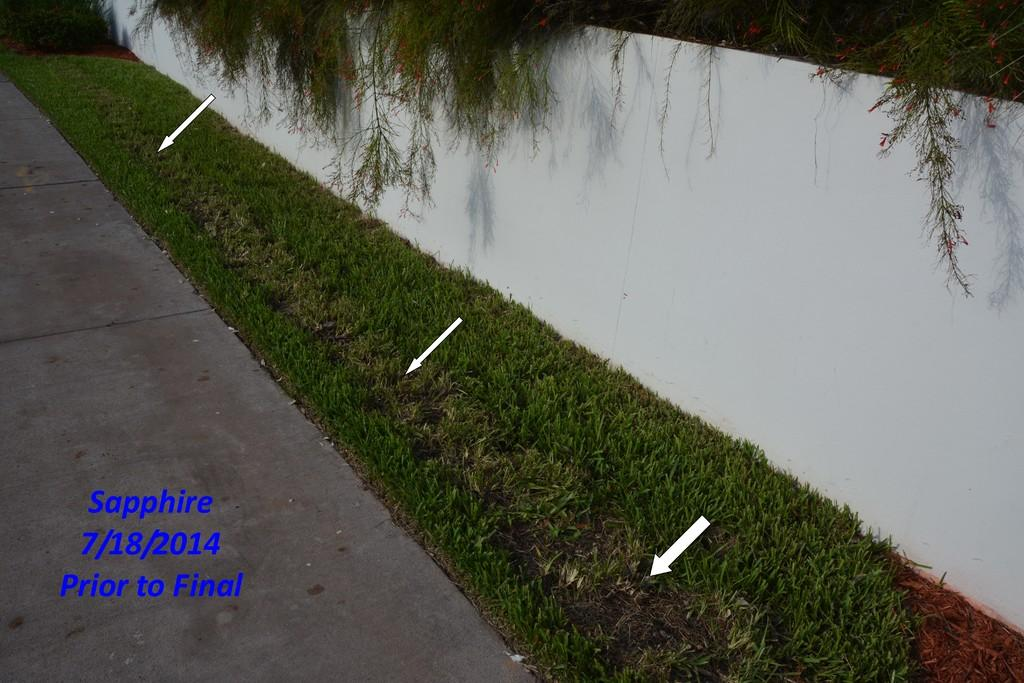What is located on the right side of the image? There is a wall on the right side of the image. What type of vegetation can be seen in the image? There is grass in the image. What is in the center of the image? There is a road in the center of the image. What is written or depicted on the road? There is text on the road. Can you tell me what type of kite is being flown in the image? There is no kite present in the image; it features a wall, grass, a road, and text on the road. What kind of meal is being prepared on the road in the image? There is no meal being prepared in the image; it only shows a wall, grass, a road, and text on the road. 